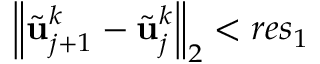<formula> <loc_0><loc_0><loc_500><loc_500>{ \left \| \tilde { u } _ { j + 1 } ^ { k } - \tilde { u } _ { j } ^ { k } \right \| } _ { 2 } < r e s _ { 1 }</formula> 